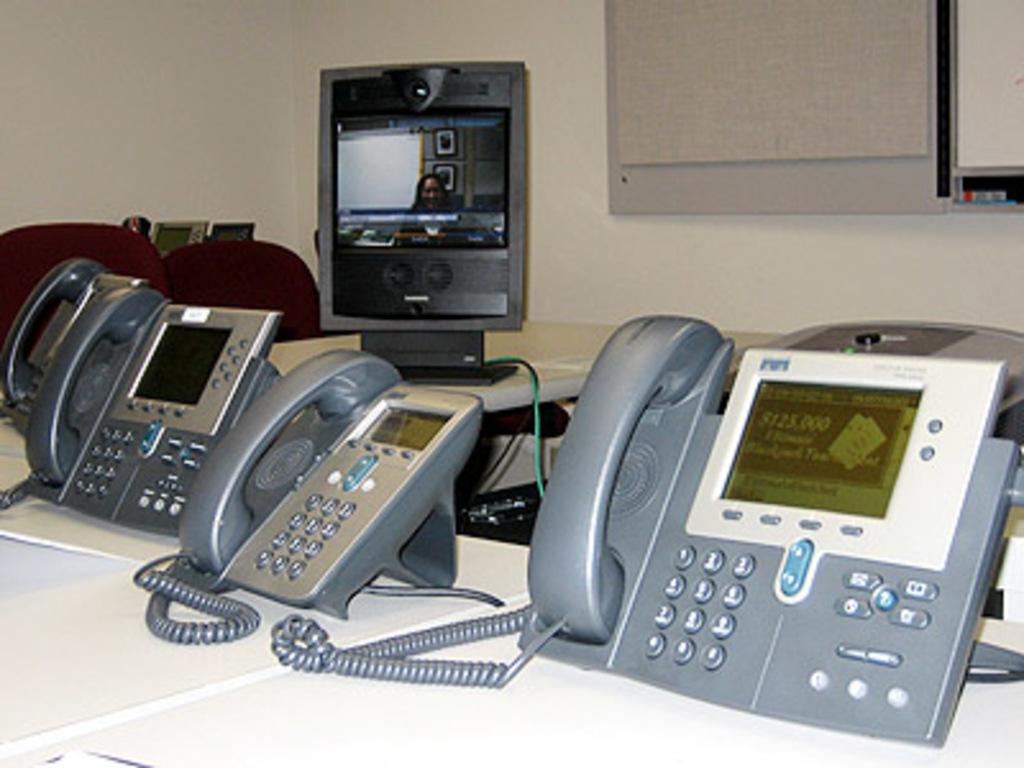Describe this image in one or two sentences. Here in this picture we can see number of telephones present on a table and we can also see a monitor present and in that we can see woman's picture visible and we can also see chairs present and we can see a board present on the wall. 